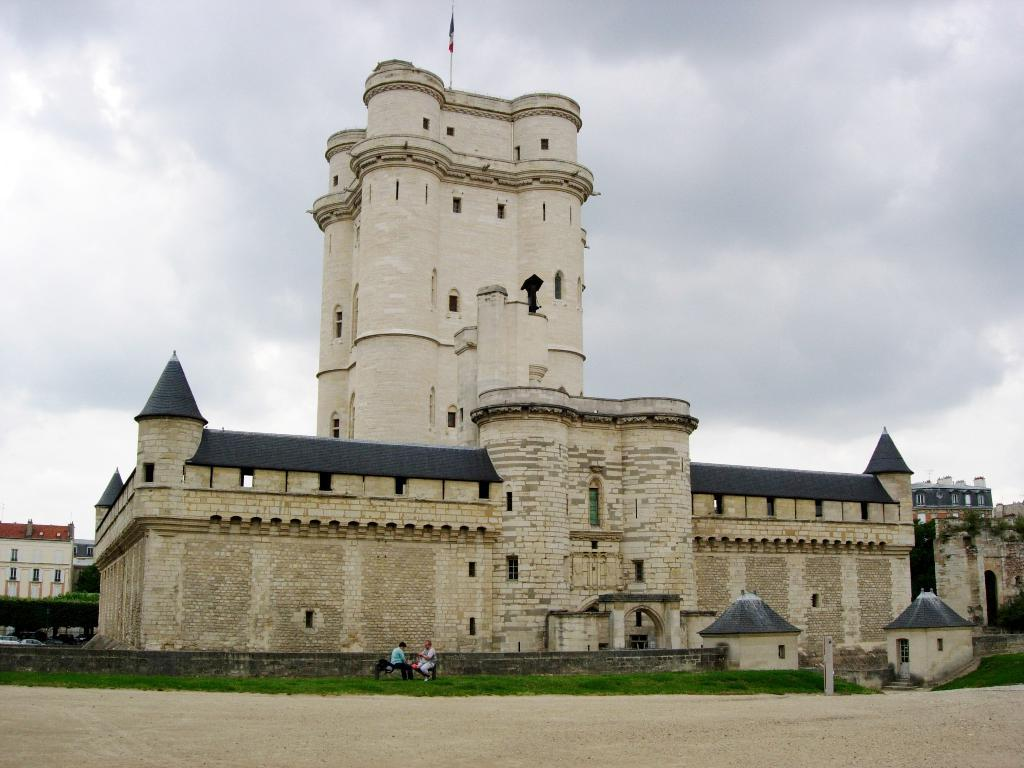What type of structures can be seen in the image? There are buildings in the image. What else can be seen in the image besides buildings? There are vehicles and a stone pillar visible in the image. Can you describe the setting where the people are sitting? Two people are sitting on a bench in the grass. What is visible in the sky in the image? There are clouds in the sky. What type of acoustics can be heard from the stone pillar in the image? There is no information about the acoustics of the stone pillar in the image, as it only provides visual details. 